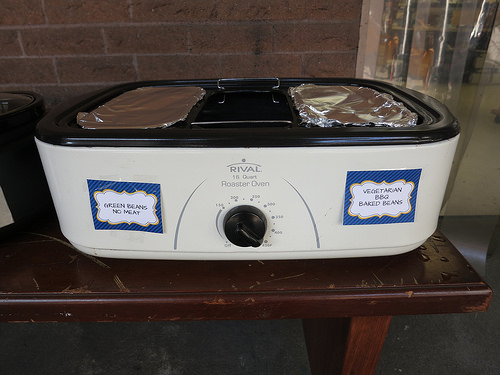<image>
Can you confirm if the note is to the left of the table? No. The note is not to the left of the table. From this viewpoint, they have a different horizontal relationship. Is the wall behind the table? Yes. From this viewpoint, the wall is positioned behind the table, with the table partially or fully occluding the wall. 